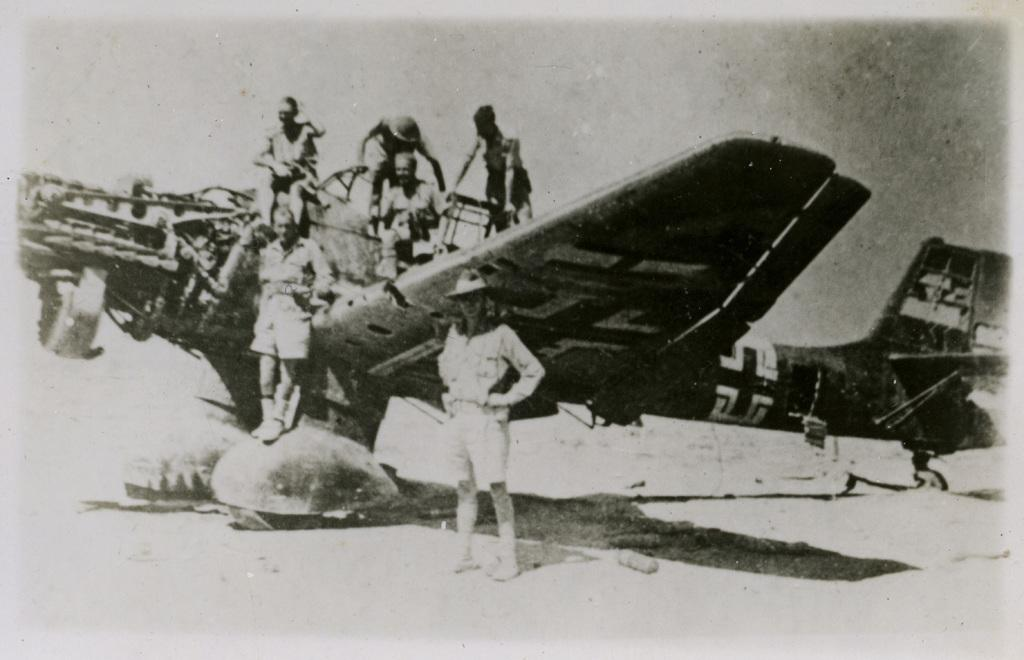What is the main subject of the image? The main subject of the image is an aircraft. Are there any people present in the image? Yes, there are people on the aircraft and a person standing to the side of the aircraft. Can you describe the condition of the image? The image is old. What type of goose can be seen crossing the bridge in the image? There is no goose or bridge present in the image; it features an aircraft with people. Can you tell me how many grandmothers are visible in the image? There is no grandmother present in the image. 